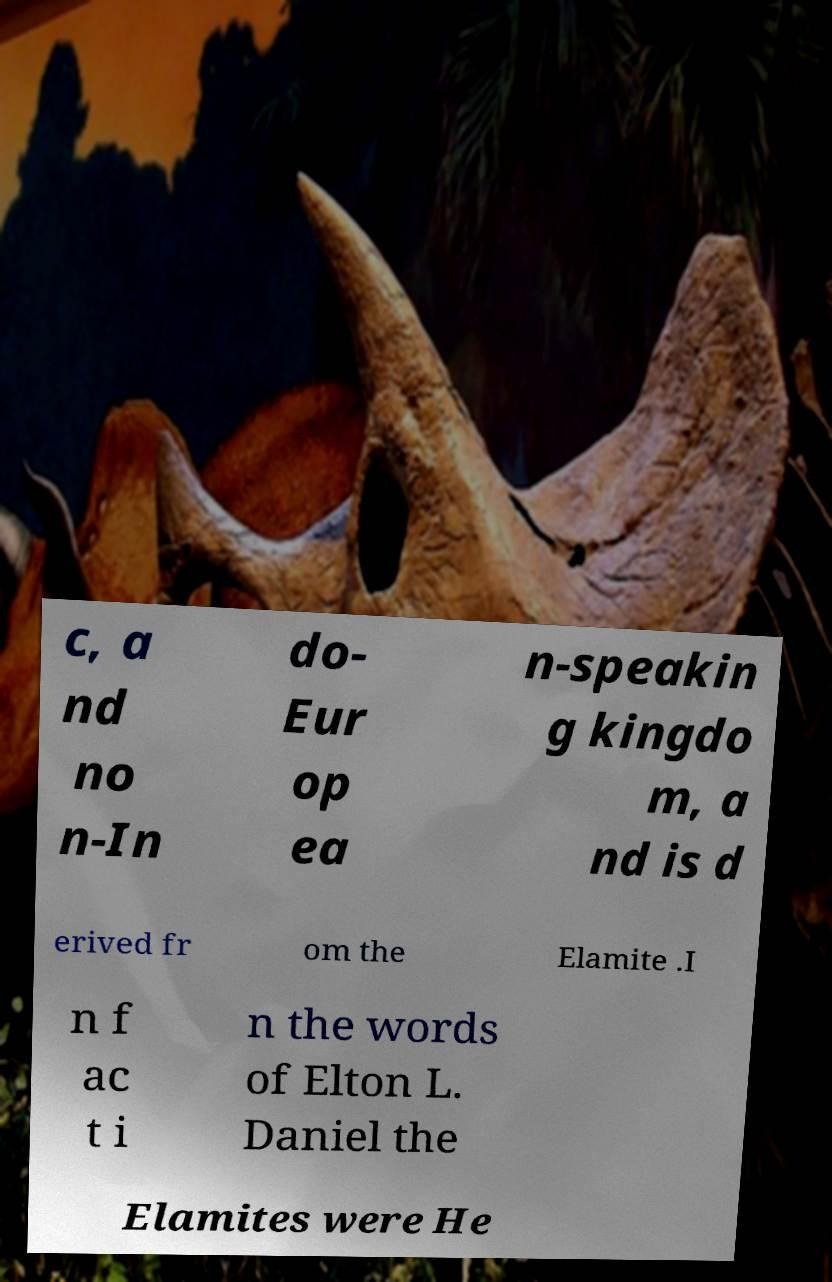Could you extract and type out the text from this image? c, a nd no n-In do- Eur op ea n-speakin g kingdo m, a nd is d erived fr om the Elamite .I n f ac t i n the words of Elton L. Daniel the Elamites were He 